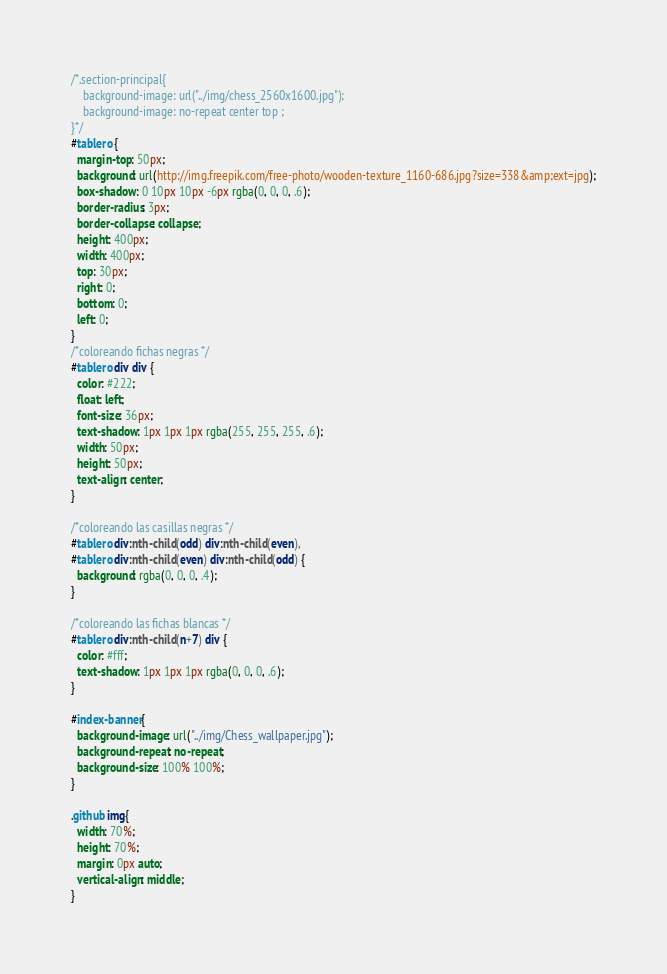<code> <loc_0><loc_0><loc_500><loc_500><_CSS_>/*.section-principal{
    background-image: url("../img/chess_2560x1600.jpg");
    background-image: no-repeat center top ;
}*/
#tablero {
  margin-top: 50px;
  background: url(http://img.freepik.com/free-photo/wooden-texture_1160-686.jpg?size=338&amp;ext=jpg);
  box-shadow: 0 10px 10px -6px rgba(0, 0, 0, .6);
  border-radius: 3px;
  border-collapse: collapse;
  height: 400px;
  width: 400px;
  top: 30px;
  right: 0;
  bottom: 0;
  left: 0;
}
/*coloreando fichas negras */
#tablero div div {
  color: #222;
  float: left;
  font-size: 36px;
  text-shadow: 1px 1px 1px rgba(255, 255, 255, .6);
  width: 50px;
  height: 50px;
  text-align: center;
}

/*coloreando las casillas negras */
#tablero div:nth-child(odd) div:nth-child(even),
#tablero div:nth-child(even) div:nth-child(odd) {
  background: rgba(0, 0, 0, .4);
}

/*coloreando las fichas blancas */
#tablero div:nth-child(n+7) div {
  color: #fff;
  text-shadow: 1px 1px 1px rgba(0, 0, 0, .6);
}

#index-banner{
  background-image: url("../img/Chess_wallpaper.jpg");
  background-repeat: no-repeat;
  background-size: 100% 100%;
}

.github img{
  width: 70%;
  height: 70%;
  margin: 0px auto;
  vertical-align: middle;
}</code> 